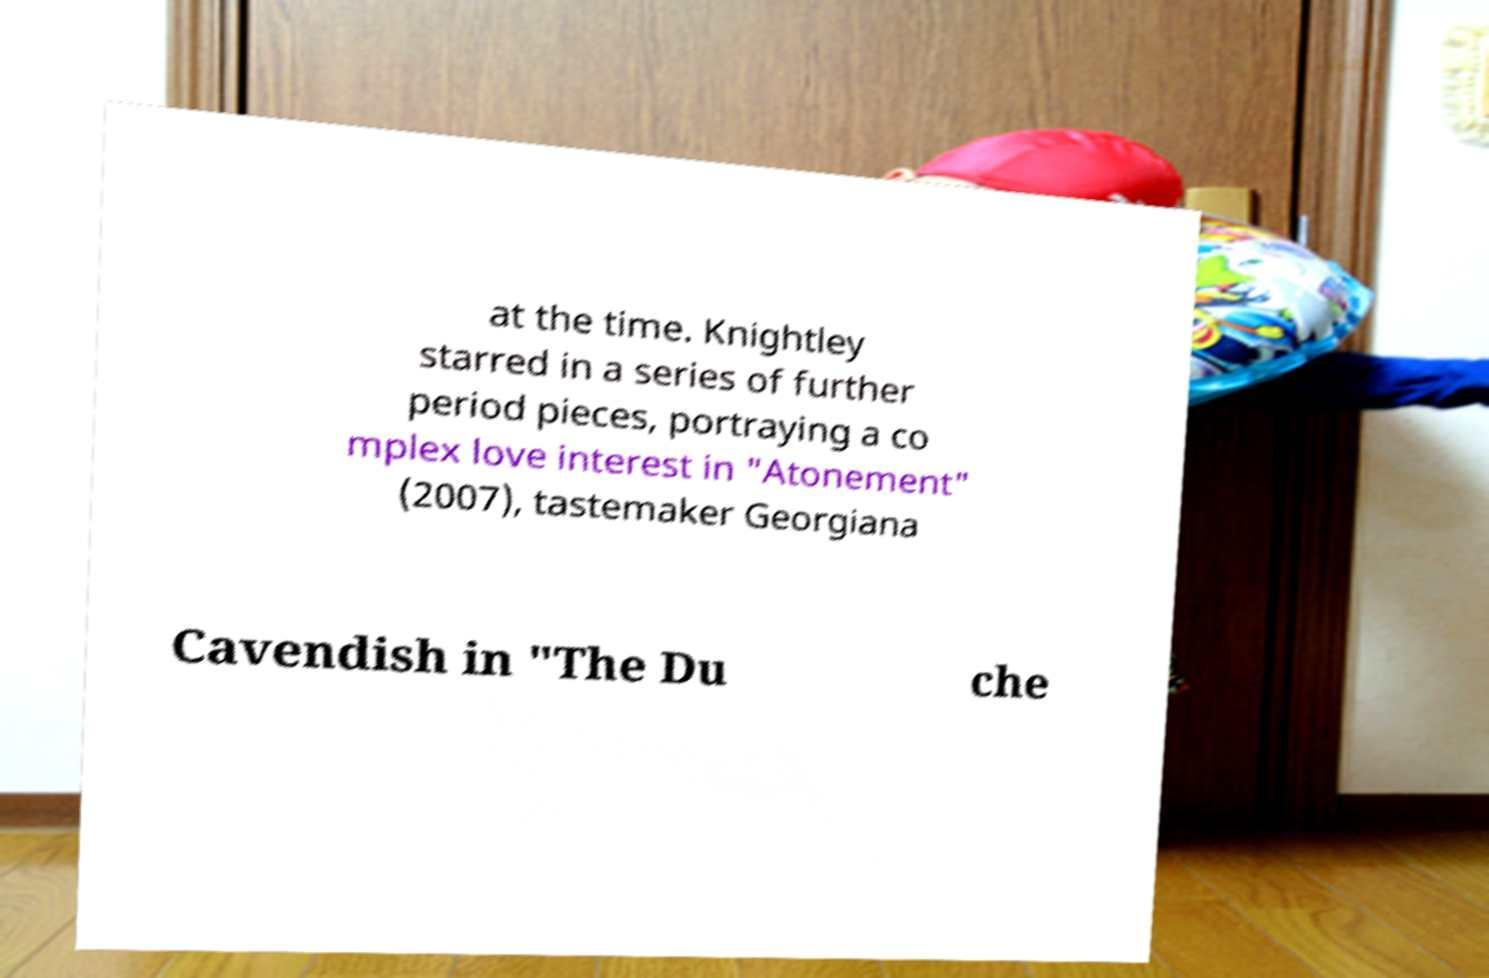Could you assist in decoding the text presented in this image and type it out clearly? at the time. Knightley starred in a series of further period pieces, portraying a co mplex love interest in "Atonement" (2007), tastemaker Georgiana Cavendish in "The Du che 